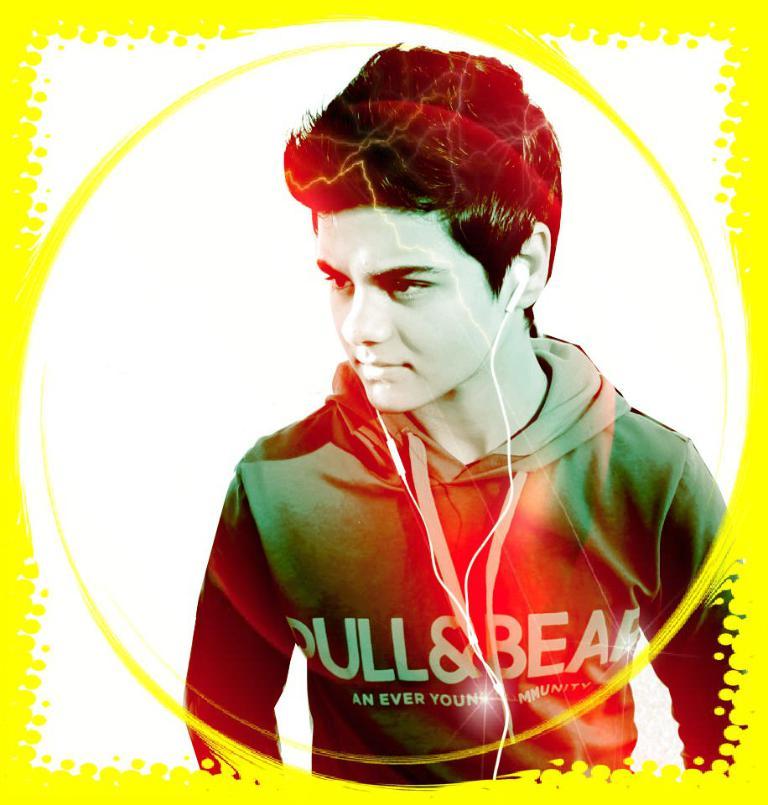What brand of clothing is represented on the youth's jacket?
Provide a short and direct response. Unanswerable. 